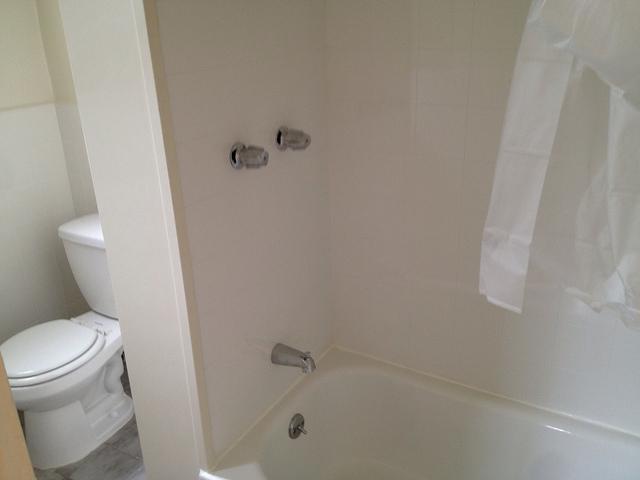Is the shower curtain hanging normally?
Concise answer only. No. What color is the toilet in the room?
Answer briefly. White. Is the water on?
Answer briefly. No. 